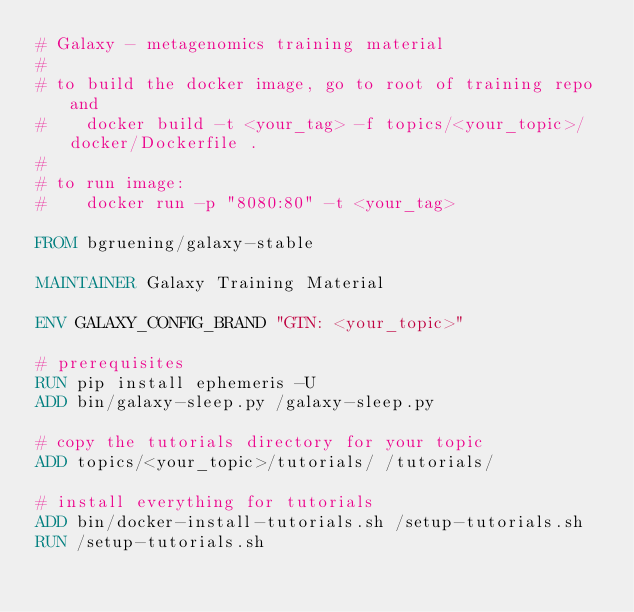<code> <loc_0><loc_0><loc_500><loc_500><_Dockerfile_># Galaxy - metagenomics training material
#
# to build the docker image, go to root of training repo and
#    docker build -t <your_tag> -f topics/<your_topic>/docker/Dockerfile .
#
# to run image:
#    docker run -p "8080:80" -t <your_tag>

FROM bgruening/galaxy-stable

MAINTAINER Galaxy Training Material

ENV GALAXY_CONFIG_BRAND "GTN: <your_topic>"

# prerequisites
RUN pip install ephemeris -U
ADD bin/galaxy-sleep.py /galaxy-sleep.py

# copy the tutorials directory for your topic
ADD topics/<your_topic>/tutorials/ /tutorials/

# install everything for tutorials
ADD bin/docker-install-tutorials.sh /setup-tutorials.sh
RUN /setup-tutorials.sh
</code> 